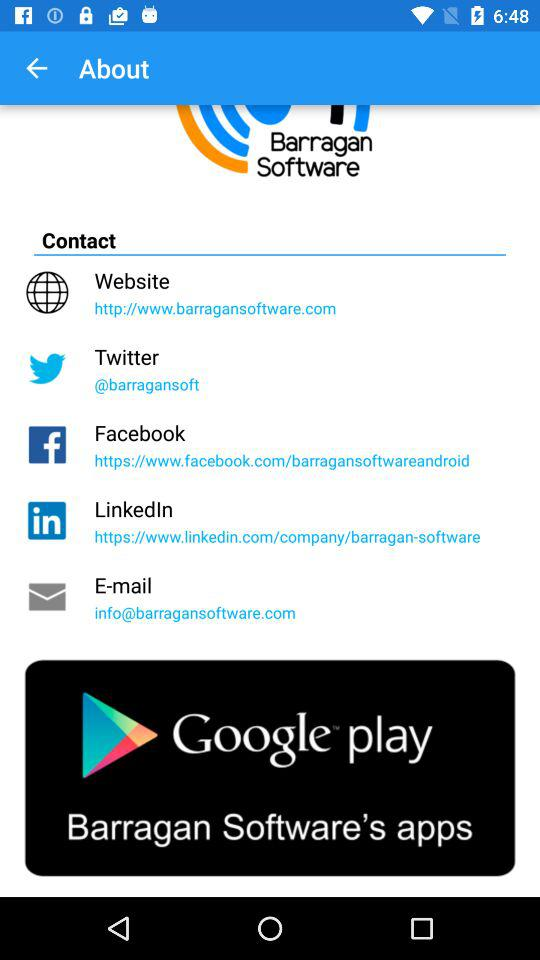What is the name of the application? The name of the application is "Barragan Software ". 